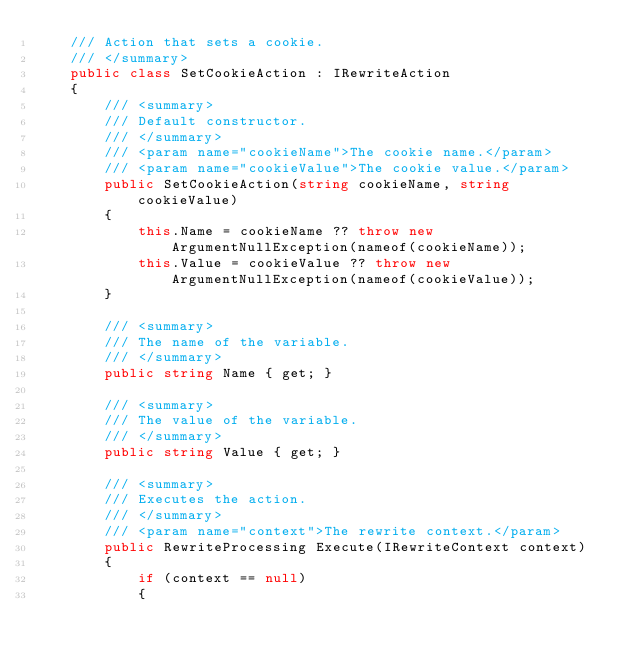Convert code to text. <code><loc_0><loc_0><loc_500><loc_500><_C#_>    /// Action that sets a cookie.
    /// </summary>
    public class SetCookieAction : IRewriteAction
    {
        /// <summary>
        /// Default constructor.
        /// </summary>
        /// <param name="cookieName">The cookie name.</param>
        /// <param name="cookieValue">The cookie value.</param>
        public SetCookieAction(string cookieName, string cookieValue)
        {
            this.Name = cookieName ?? throw new ArgumentNullException(nameof(cookieName));
            this.Value = cookieValue ?? throw new ArgumentNullException(nameof(cookieValue));
        }

        /// <summary>
        /// The name of the variable.
        /// </summary>
        public string Name { get; }

        /// <summary>
        /// The value of the variable.
        /// </summary>
        public string Value { get; }

        /// <summary>
        /// Executes the action.
        /// </summary>
        /// <param name="context">The rewrite context.</param>
        public RewriteProcessing Execute(IRewriteContext context)
        {
            if (context == null)
            {</code> 